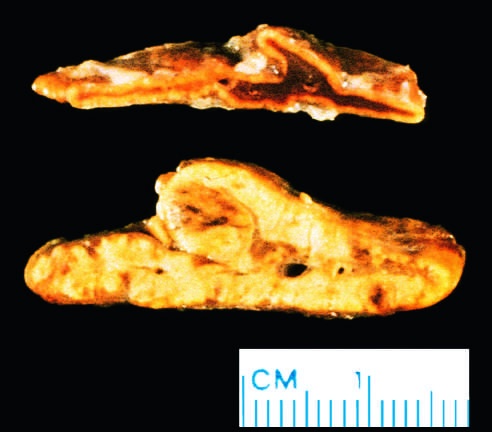how is diffuse hyperplasia of the adrenal gland contrasted?
Answer the question using a single word or phrase. With a normal adrenal gland 